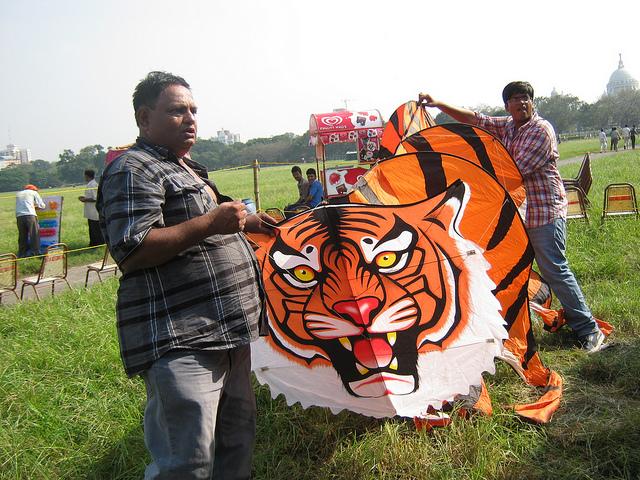Is this midday?
Concise answer only. Yes. Is the animal alive?
Give a very brief answer. No. What is the surface the two men are standing on?
Answer briefly. Grass. 